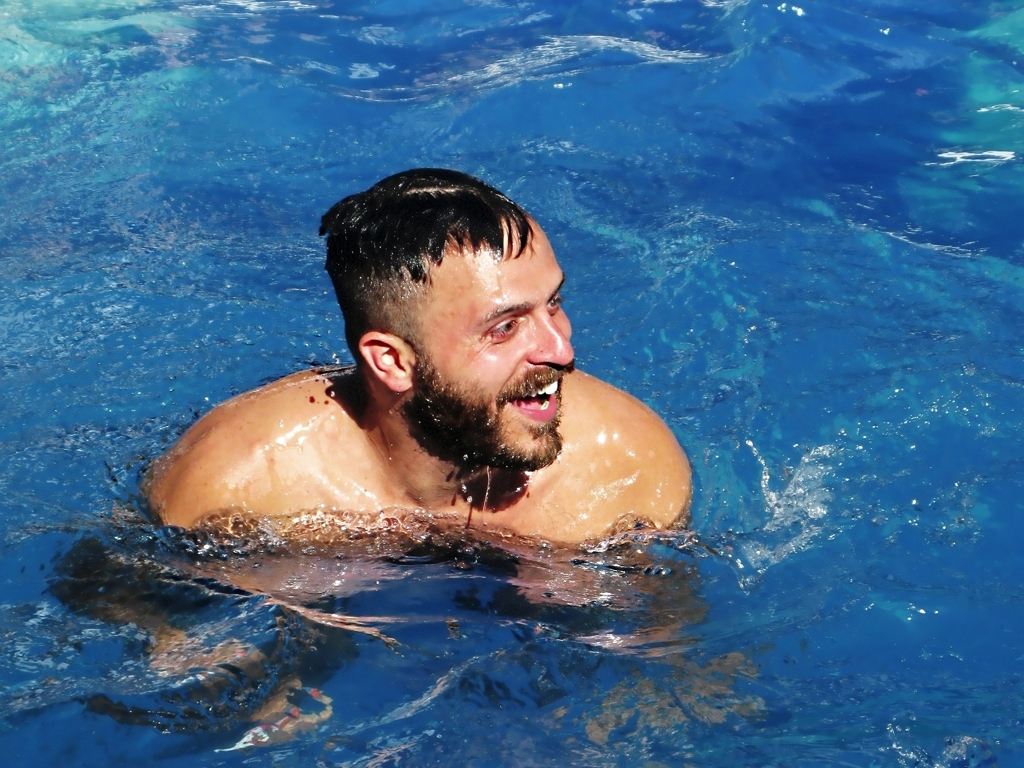What kind of emotions does this image evoke? The man's expression, with a wide smile and sparkling eyes, emits a sense of joy and delight. The overall mood seems carefree and relaxed, capturing what could be a moment of leisure or fun during a refreshing swim. 